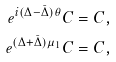<formula> <loc_0><loc_0><loc_500><loc_500>e ^ { i ( \Delta - \bar { \Delta } ) \theta } C & = C , \\ e ^ { ( \Delta + \bar { \Delta } ) \mu _ { 1 } } C & = C ,</formula> 